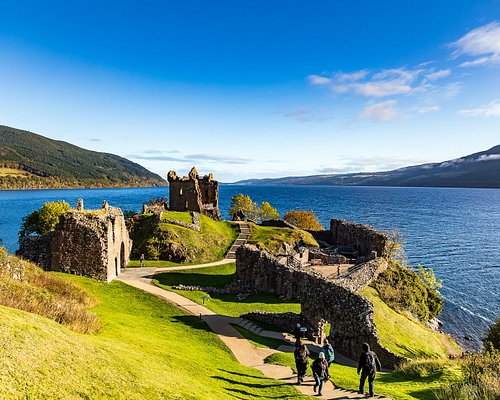What historical events took place at Urquhart Castle? Urquhart Castle has been pivotal in numerous historical events, particularly during the Scottish struggle for independence. It was frequently captured and recaptured in the conflicts between the Scots and English in the 14th and 15th centuries, serving as a stronghold due to its strategic location. It's also notably involved in the Wars of Scottish Independence and has witnessed visits from figures like Robert the Bruce. 